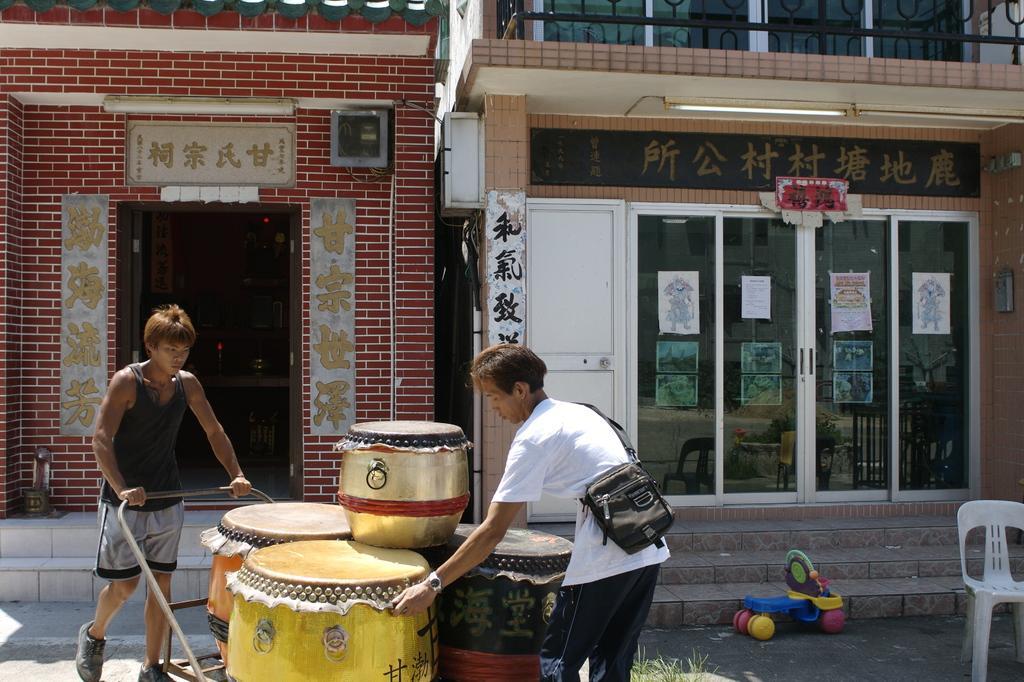Can you describe this image briefly? Here in this picture, in the front we can see two persons present on the ground and one person is pulling the trolley and the other is managing the drums and barrels present on the trolley and we can see the person on the right side is carrying a bag and beside him we can see a toy and a chair present and we can also see a store with doors present and we can also see a hoarding present and we can see some posters pasted on the walls present. 